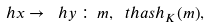Convert formula to latex. <formula><loc_0><loc_0><loc_500><loc_500>\ h x \rightarrow \ h y \, \colon \, m , \ t h a s h _ { K } ( m ) ,</formula> 